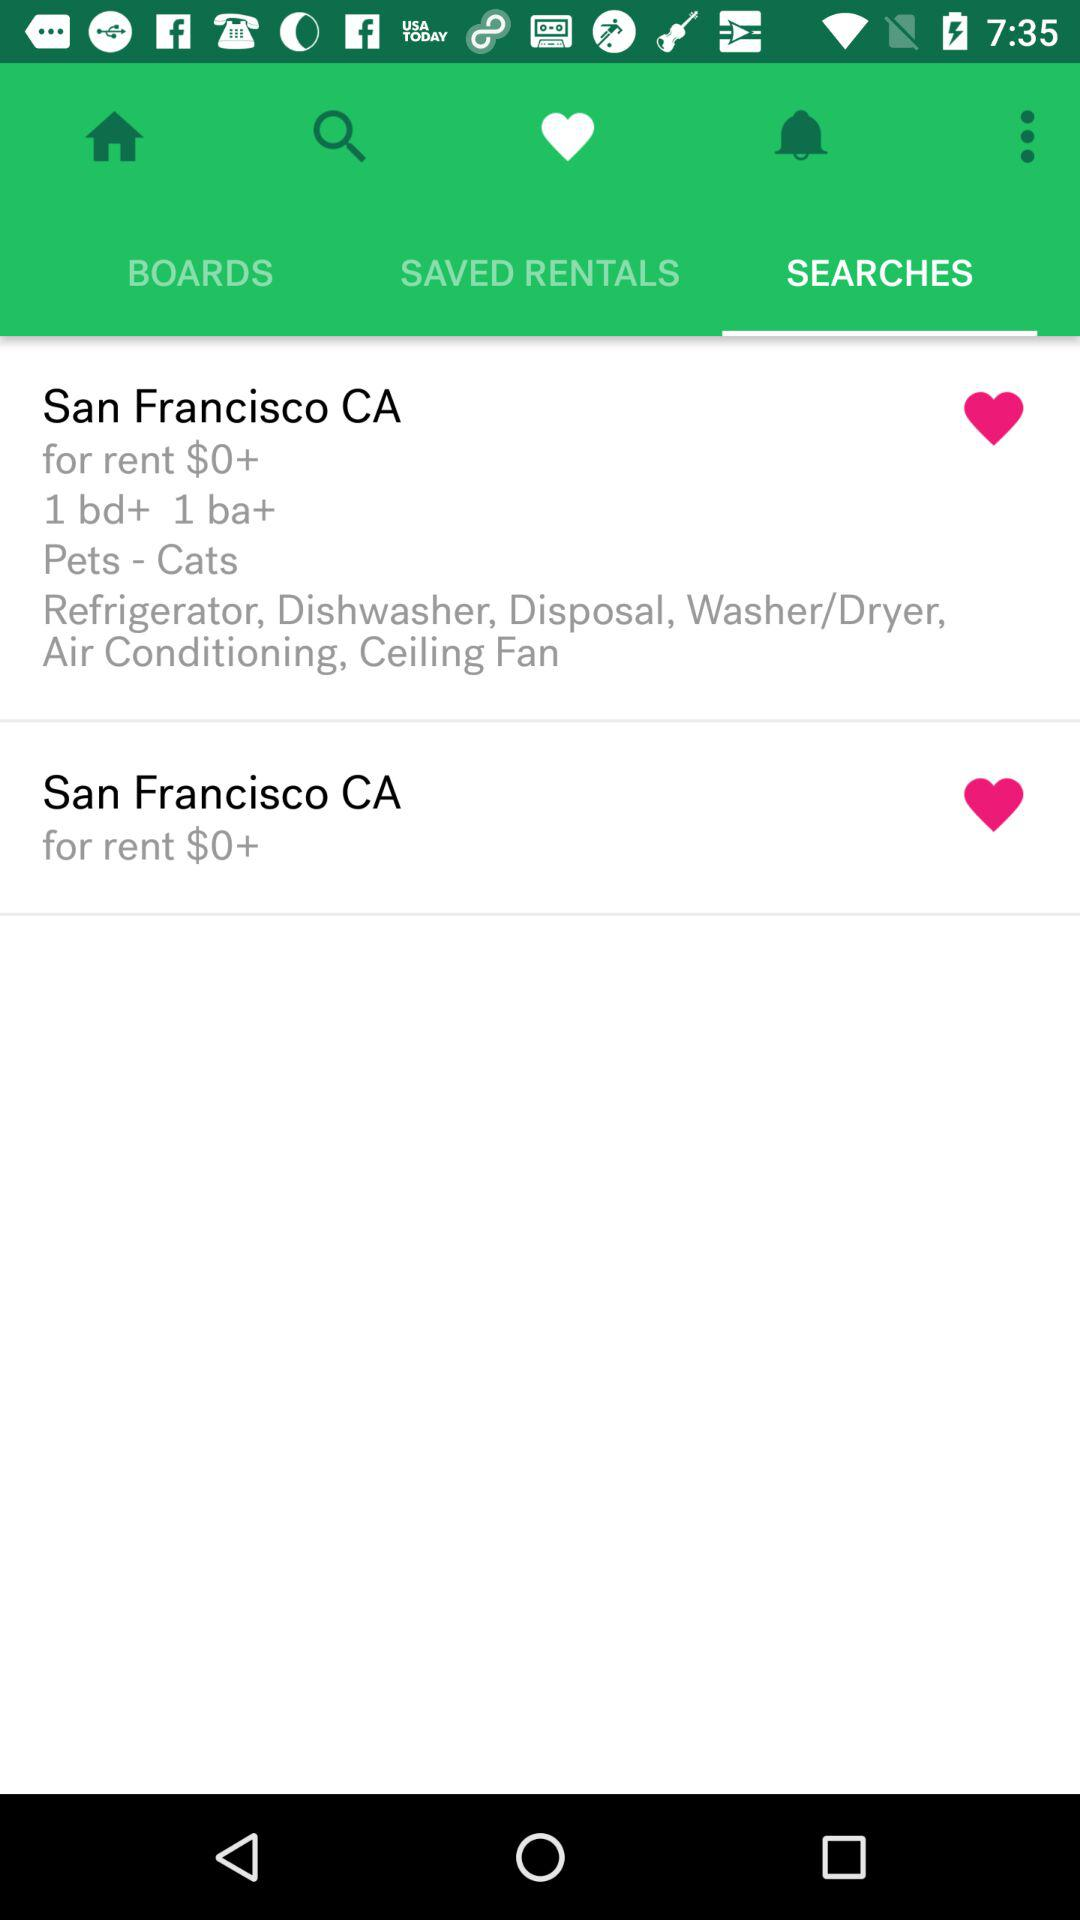How many bedrooms and bathrooms are there in San Francisco, CA? There is 1 bedroom and 1 bathroom. 